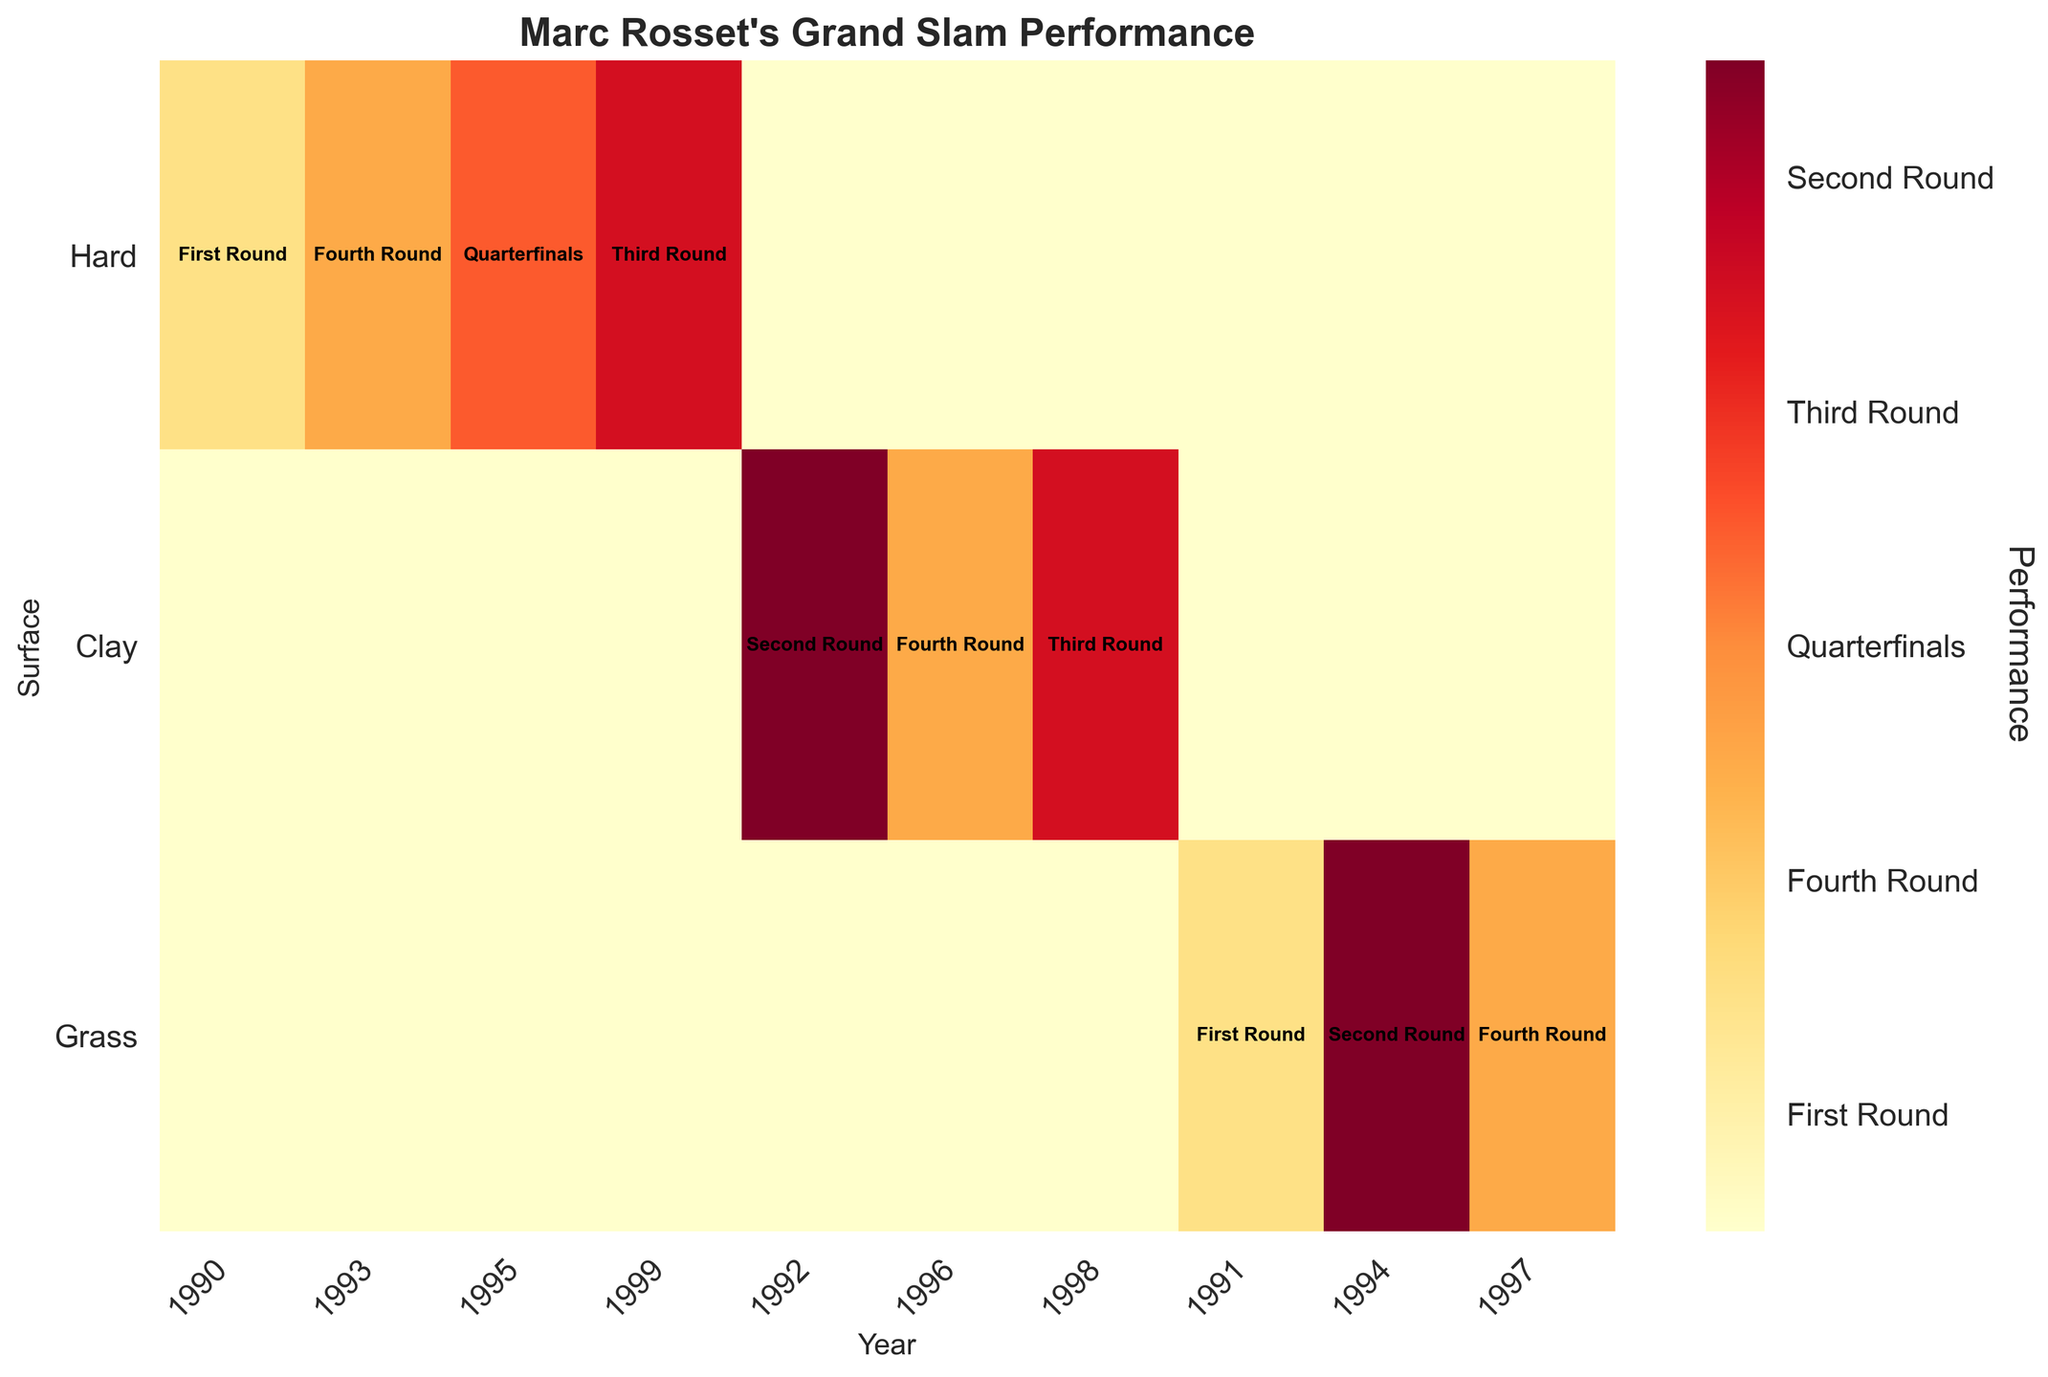What is the title of the figure? The title of the figure is usually located at the top and is prominently displayed in a larger and bold font to summarize the content.
Answer: "Marc Rosset's Grand Slam Performance" On which surface did Marc Rosset reach the quarterfinals in 1995? To find the answer, look for the row labeled "Hard" (surface type) and then locate the column labeled "1995". Read the performance indicated in that cell.
Answer: Hard In which year did Marc Rosset reach the Fourth Round on Clay? Locate the row labeled "Clay" and find the year where the performance shown is "Fourth Round".
Answer: 1996 How many times did Marc Rosset reach the Third Round across all surfaces? Count the number of cells in the mosaic plot across all rows labeled with "Third Round".
Answer: 2 Did Marc Rosset ever reach the Fourth Round on Grass? Check the row labeled "Grass" to see if any cell contains the "Fourth Round" performance.
Answer: Yes Which year had the highest variety of performances by Marc Rosset? Count the unique types of performances across different surfaces for each year and find the year with the highest count.
Answer: 1996 (Fourth Round on Clay) Compare Marc Rosset's performance in 1990 on Hard and Grass surfaces. Check the cells for 1990 in the rows for "Hard" and "Grass" to see the performances and compare.
Answer: Hard: First Round, Grass: N/A Which surface saw Marc Rosset's best performance, and what was it? Identify the surface row with the highest performance level across all years. Quarterfinals is the highest, so look for where it appears.
Answer: Hard, Quarterfinals How many different performances did Marc Rosset achieve on Clay? Count the unique performance labels in the "Clay" row.
Answer: 3 (Second Round, Third Round, Fourth Round) What is the color associated with "Fourth Round" in the colorbar? Look at the colorbar legend on the right side of the plot and find the color corresponding to "Fourth Round" label.
Answer: Orange (assuming standard color mapping) 